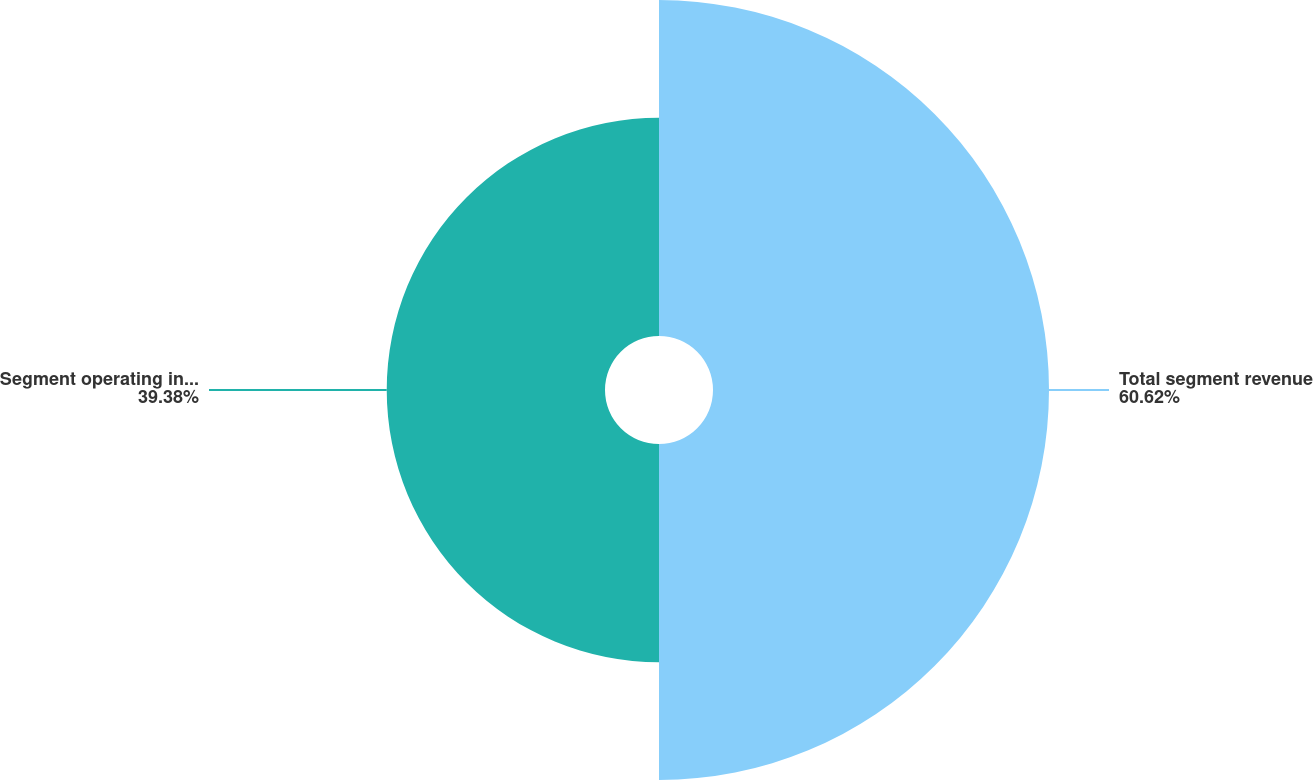<chart> <loc_0><loc_0><loc_500><loc_500><pie_chart><fcel>Total segment revenue<fcel>Segment operating income<nl><fcel>60.62%<fcel>39.38%<nl></chart> 